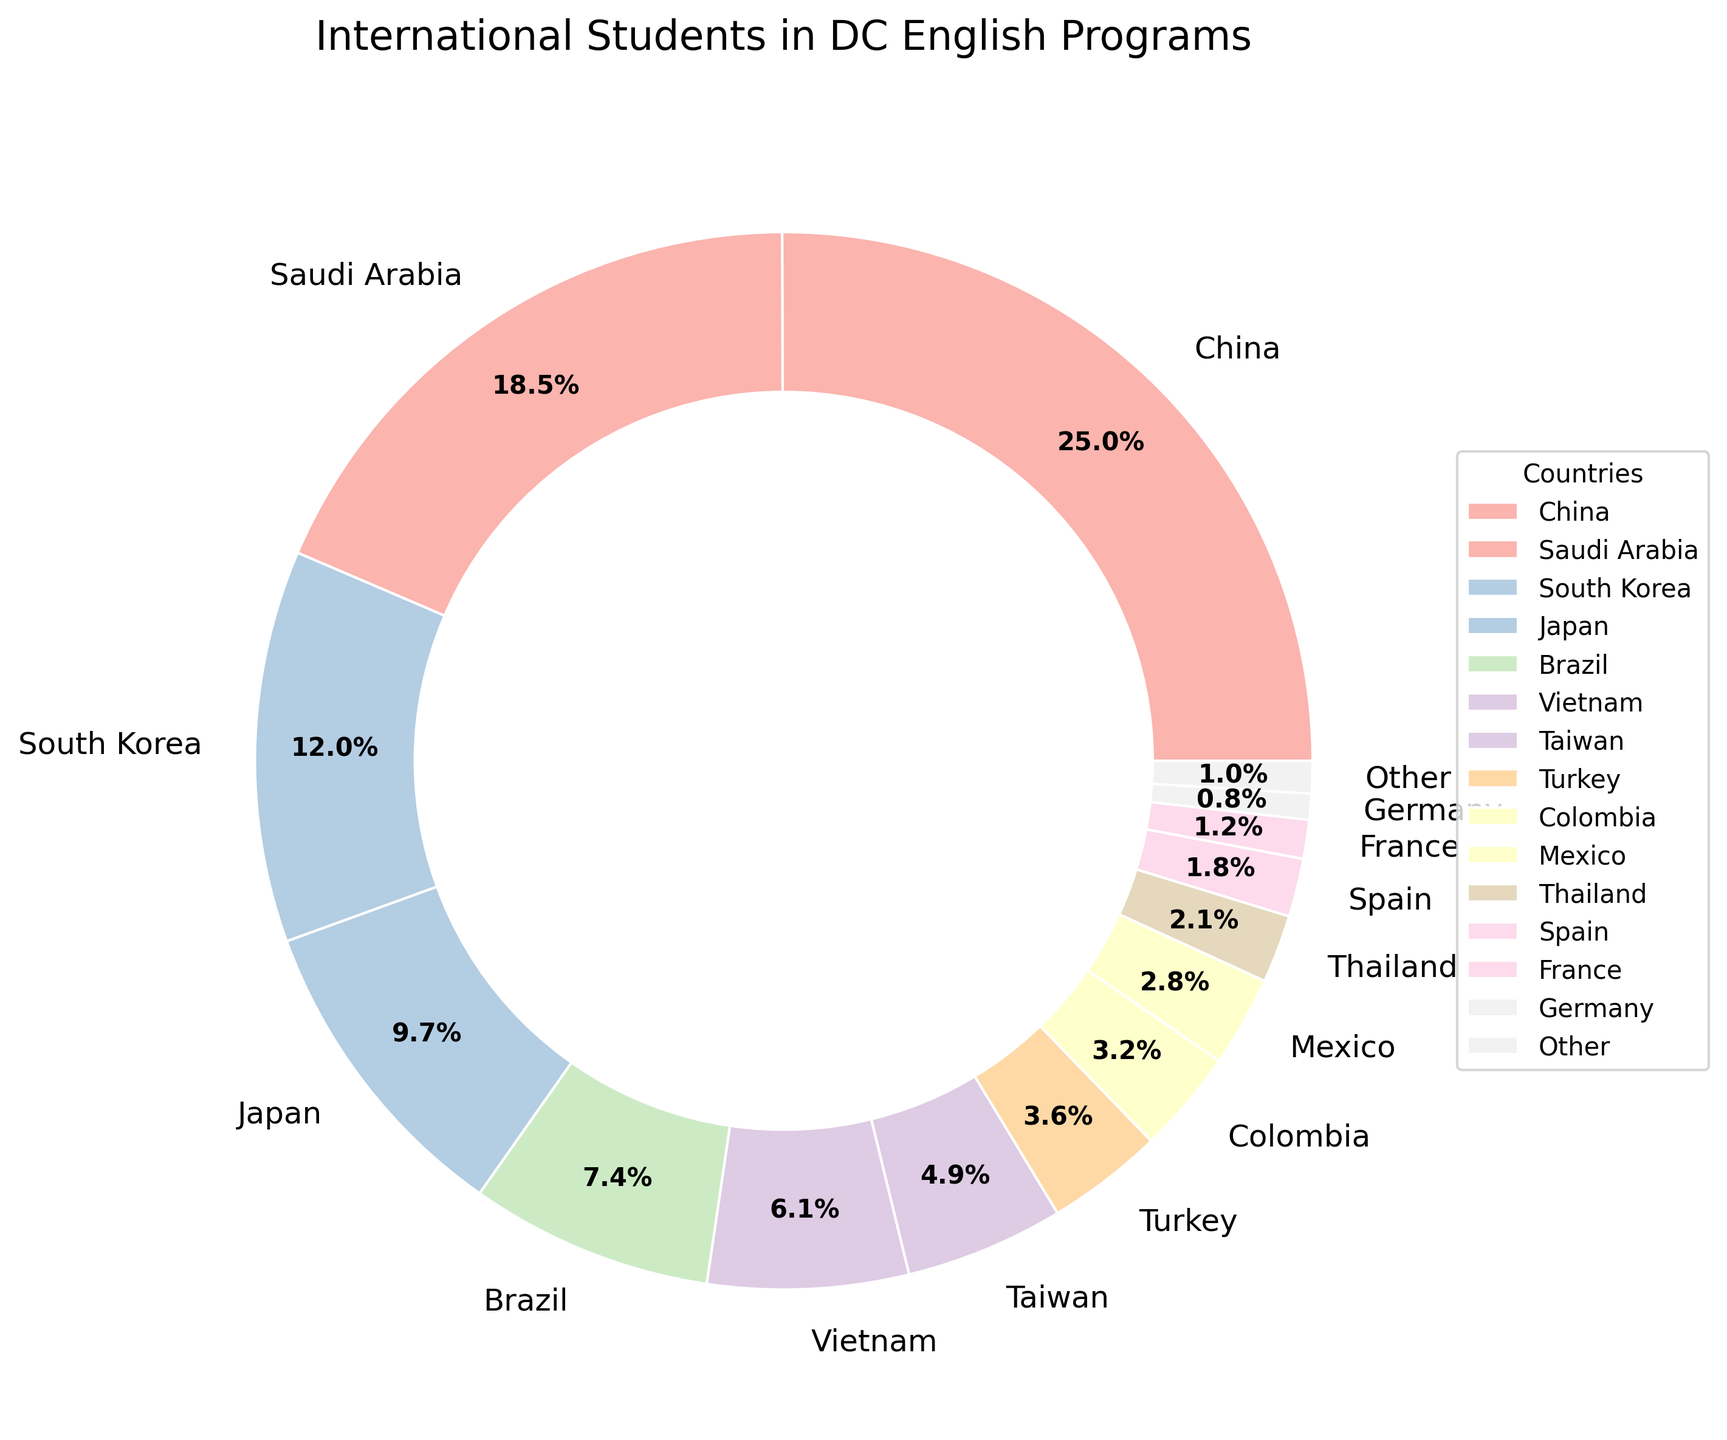What proportion of international students come from China and Saudi Arabia combined? To find the combined proportion of students from China and Saudi Arabia, add their percentages: 25.3% (China) + 18.7% (Saudi Arabia) = 44%.
Answer: 44% Which country has the largest proportion of students in DC English programs, and what is that proportion? The country with the largest proportion of students is represented by the largest slice of the pie chart. China has the largest slice, with 25.3%.
Answer: China, 25.3% Is the number of students from Japan greater than the number of students from Brazil? Compare the percentage slices of Japan and Brazil from the pie chart. Japan has 9.8%, and Brazil has 7.5%. Since 9.8% > 7.5%, the number of students from Japan is greater.
Answer: Yes How many times larger is the proportion of students from South Korea compared to that from Germany? To determine how many times larger, divide the percentage of South Korean students by the percentage of German students: 12.1% / 0.8% = 15.125.
Answer: 15.125 What is the combined proportion of students from the top three countries? The top three countries are China (25.3%), Saudi Arabia (18.7%), and South Korea (12.1%). Sum their percentages: 25.3% + 18.7% + 12.1% = 56.1%.
Answer: 56.1% Compare the proportion of students from Taiwan and Turkey. Which country has a higher proportion? Look at the slices representing Taiwan (4.9%) and Turkey (3.6%). Since 4.9% > 3.6%, Taiwan has a higher proportion.
Answer: Taiwan Which countries have a proportion of students between 5% and 10%? Identify the countries within the 5%-10% range by examining the slices. Japan (9.8%) and Brazil (7.5%) fall in this range.
Answer: Japan and Brazil What is the difference in proportion between the number of students from Vietnam and those from Mexico? Subtract the percentage of Mexican students (2.8%) from the percentage of Vietnamese students (6.2%): 6.2% - 2.8% = 3.4%.
Answer: 3.4% How many countries have a proportion less than 3%? Count the slices with percentages less than 3%. The countries are Mexico (2.8%), Thailand (2.1%), Spain (1.8%), France (1.2%), Germany (0.8%) and Other (1.0%), totaling 6 countries.
Answer: 6 